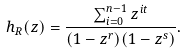<formula> <loc_0><loc_0><loc_500><loc_500>h _ { R } ( z ) = \frac { \sum _ { i = 0 } ^ { n - 1 } z ^ { i t } } { ( 1 - z ^ { r } ) ( 1 - z ^ { s } ) } .</formula> 